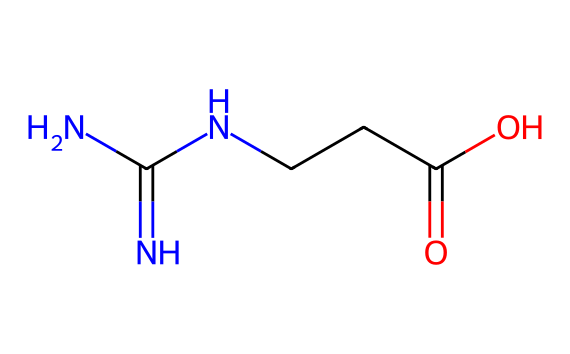What is the name of this chemical? The chemical's name can be determined by looking at its structure and recognizing its functional groups. The presence of the guanidino group (–C(=N)N–) and the carboxylic acid group (–C(=O)O) indicates it is creatine.
Answer: creatine How many nitrogen atoms are present? By examining the chemical structure, we can count the nitrogen atoms. There are three nitrogen atoms visible in the structure: two in the guanidino part and one attached to the amino group.
Answer: three What type of functional groups are present in this structure? The structure contains an amino group (–NH2), a guanidino group (–C(=N)N–), and a carboxylic acid group (–C(=O)O). This diversity of functional groups helps in its biochemical roles.
Answer: amino, guanidino, carboxylic acid What is the molecular formula derived from this SMILES representation? To derive the molecular formula, we need to identify the number of each type of atom from the structure: there are 4 carbons, 9 hydrogens, 3 nitrogens, and 2 oxygens, leading to the molecular formula C4H9N3O2.
Answer: C4H9N3O2 How many carbon atoms does creatine have? By analyzing the structure, the number of carbon atoms can be counted directly. In this case, there are four carbon atoms visible in the structure of creatine.
Answer: four What role does the carboxylic acid group play in the function of creatine? The carboxylic acid group helps in the solubility of creatine in water and plays a crucial role in its interaction with other molecules in metabolism and muscle function.
Answer: solubility and interaction In what type of reactions can this chemical participate due to its structure? Given the presence of the carboxylic acid and amine groups, creatine can participate in acid-base reactions, and it can also undergo nucleophilic substitutions due to its functional groups.
Answer: acid-base reactions, nucleophilic substitutions 